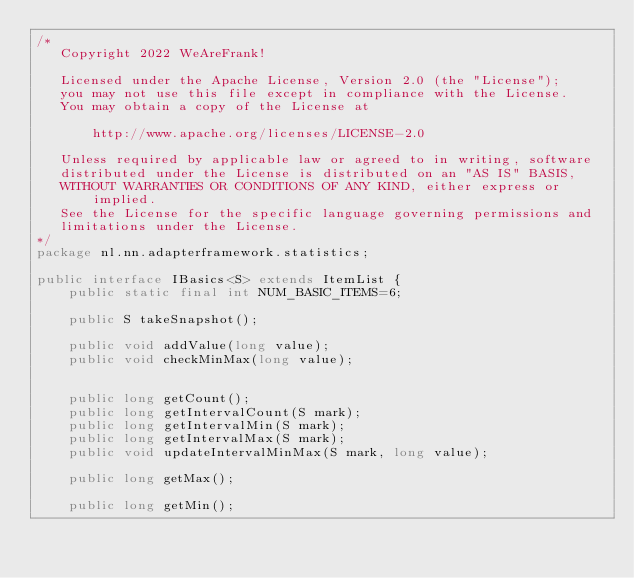<code> <loc_0><loc_0><loc_500><loc_500><_Java_>/*
   Copyright 2022 WeAreFrank!

   Licensed under the Apache License, Version 2.0 (the "License");
   you may not use this file except in compliance with the License.
   You may obtain a copy of the License at

       http://www.apache.org/licenses/LICENSE-2.0

   Unless required by applicable law or agreed to in writing, software
   distributed under the License is distributed on an "AS IS" BASIS,
   WITHOUT WARRANTIES OR CONDITIONS OF ANY KIND, either express or implied.
   See the License for the specific language governing permissions and
   limitations under the License.
*/
package nl.nn.adapterframework.statistics;

public interface IBasics<S> extends ItemList {
	public static final int NUM_BASIC_ITEMS=6;

	public S takeSnapshot();

	public void addValue(long value);
	public void checkMinMax(long value);


	public long getCount();
	public long getIntervalCount(S mark);
	public long getIntervalMin(S mark);
	public long getIntervalMax(S mark);
	public void updateIntervalMinMax(S mark, long value);

	public long getMax();

	public long getMin();
</code> 